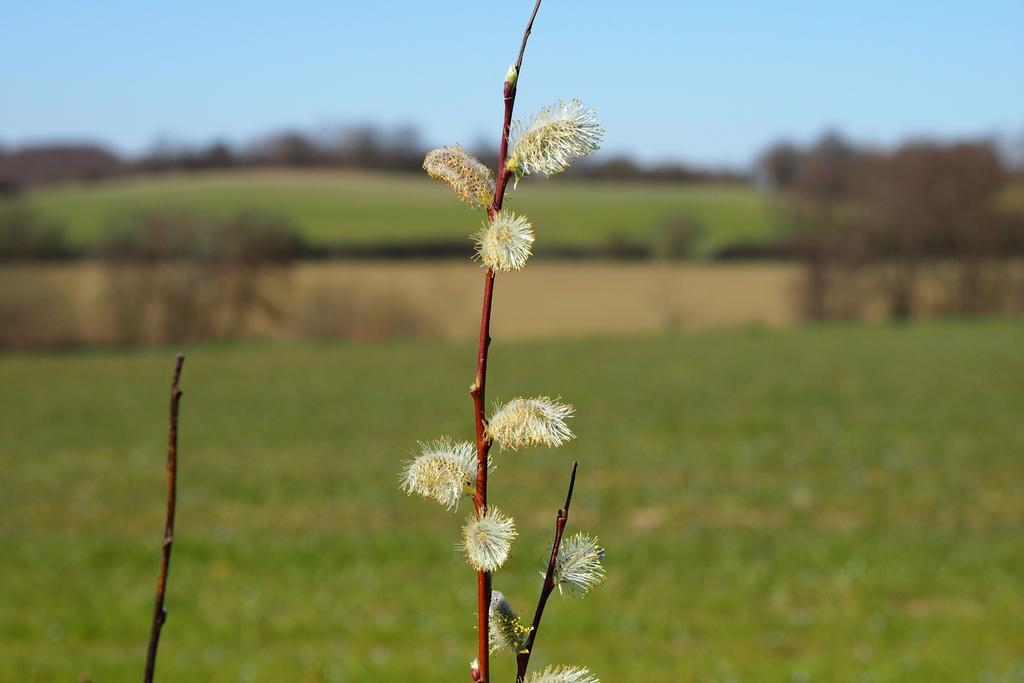What is the main subject in the center of the image? There is a plant in the center of the image. What part of the plant is visible? The stem of the plant is visible. What type of vegetation can be seen in the background of the image? There are trees in the background of the image. What else is visible in the background of the image? The sky is visible in the background of the image. What type of cloth is draped over the plant in the image? There is no cloth present in the image; it features a plant with a visible stem. What street is the plant located on in the image? The image does not depict a street; it shows a plant with a visible stem, trees in the background, and the sky. 